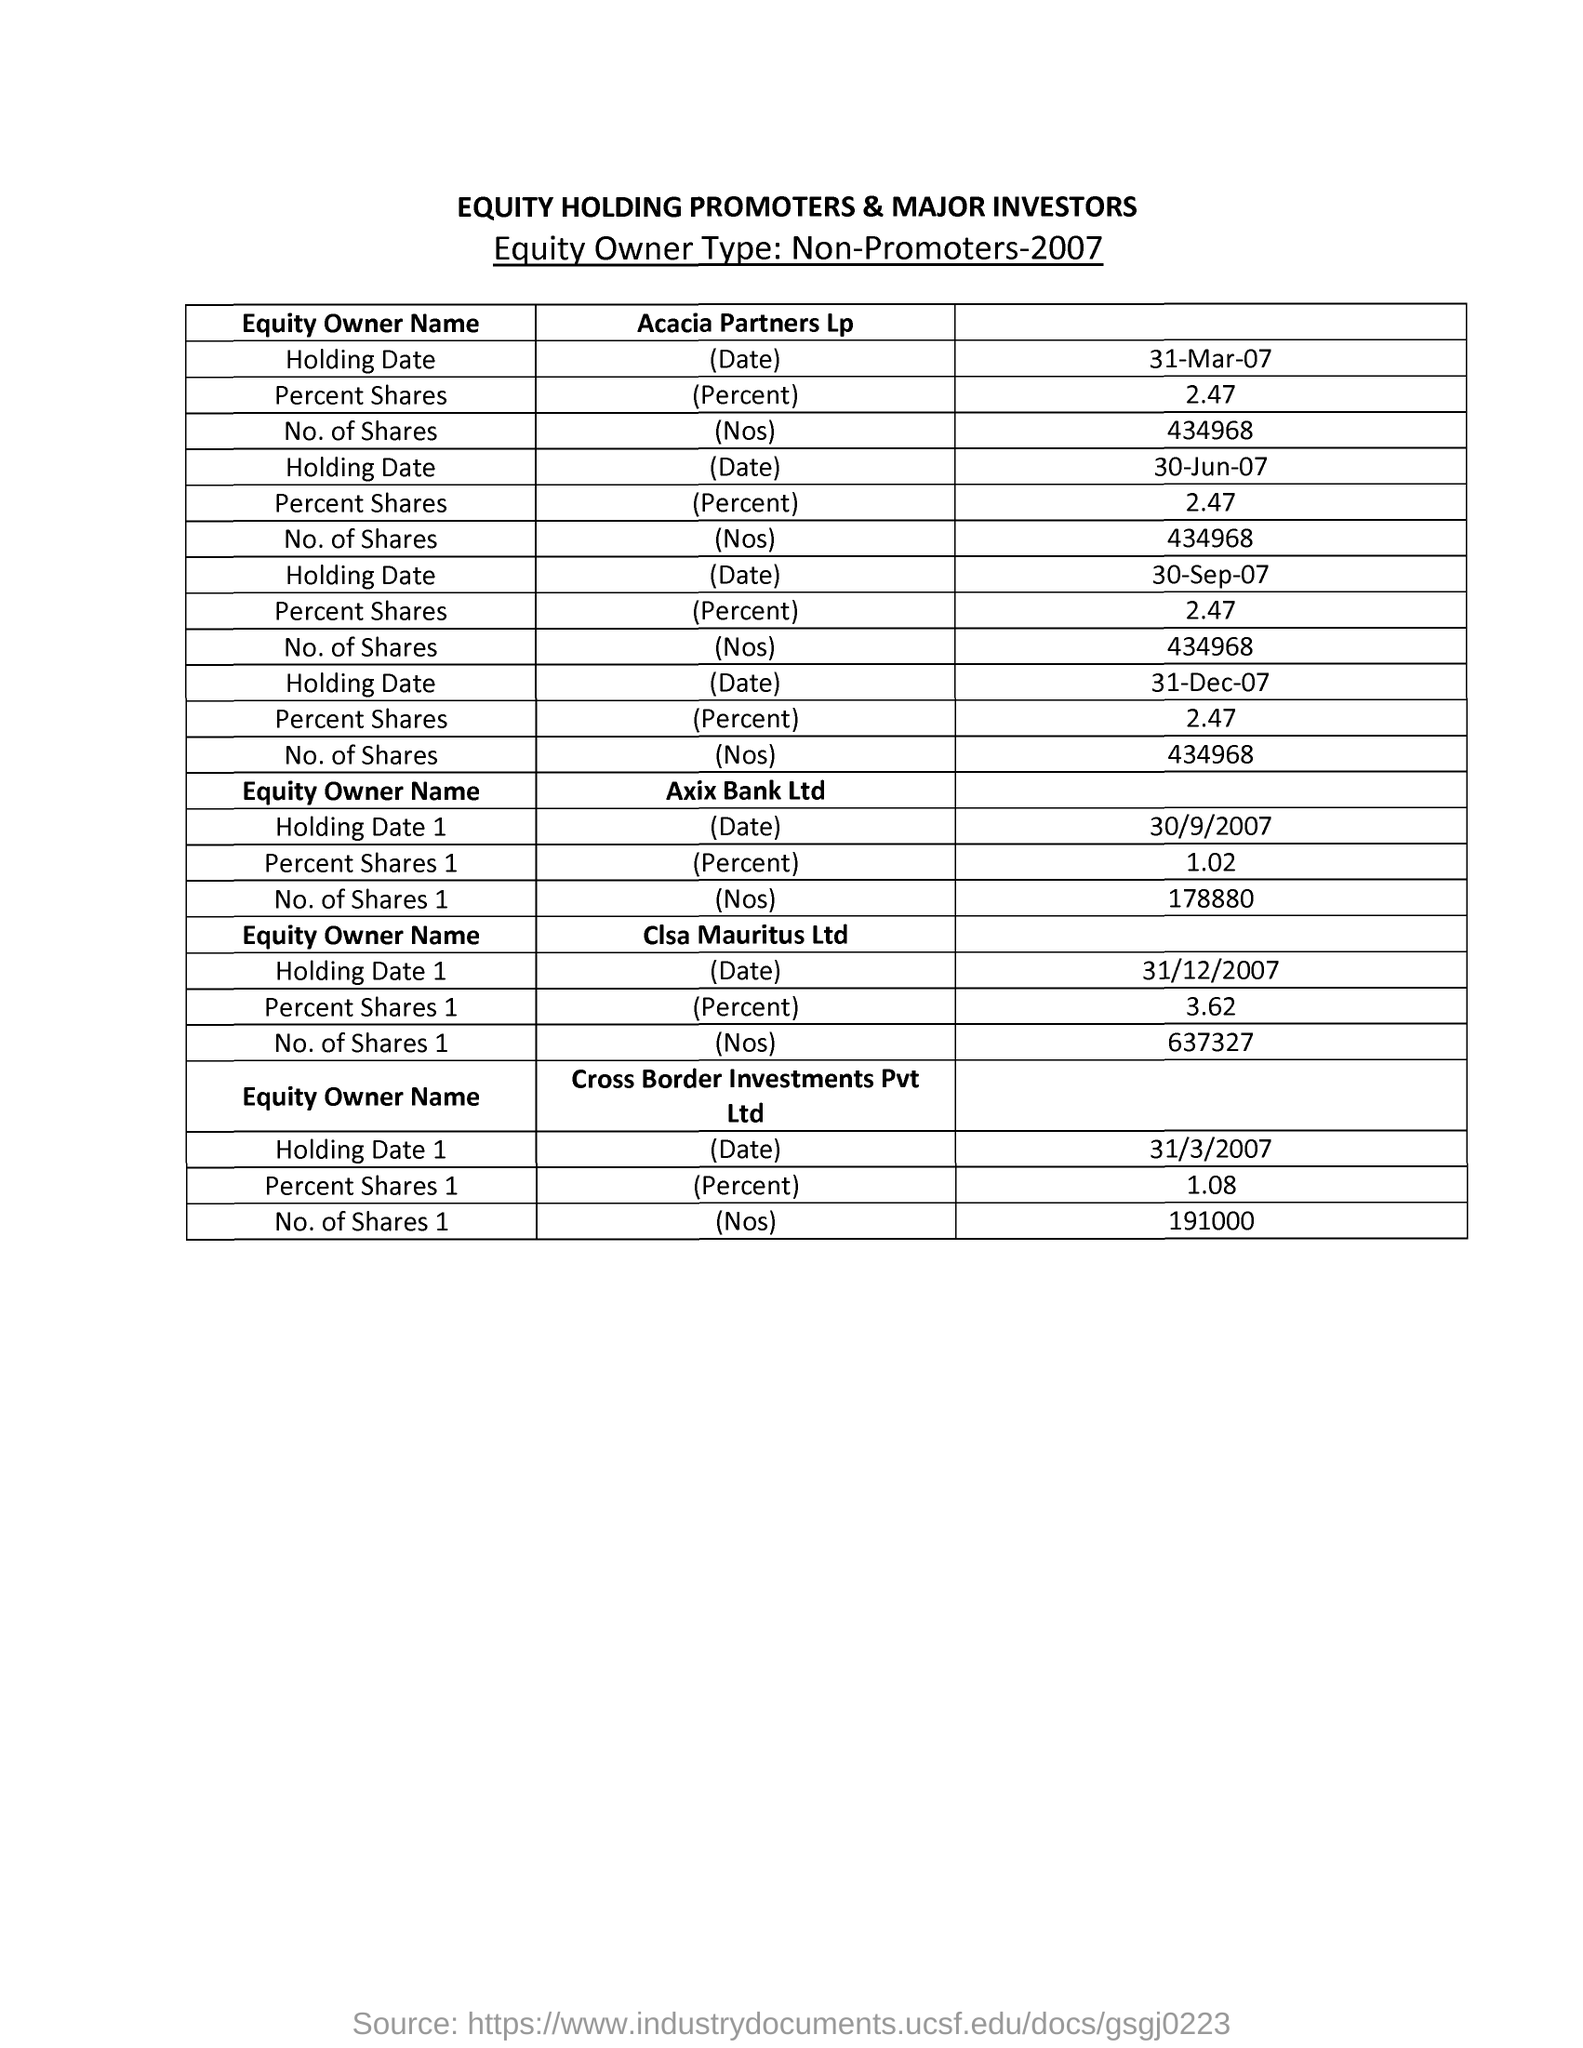Point out several critical features in this image. Clsa Mauritus Ltd held 3.62% of the total shares. Axis Bank Ltd had 178,880 shares. The holding date of Axis Bank Ltd was September 30, 2007. 